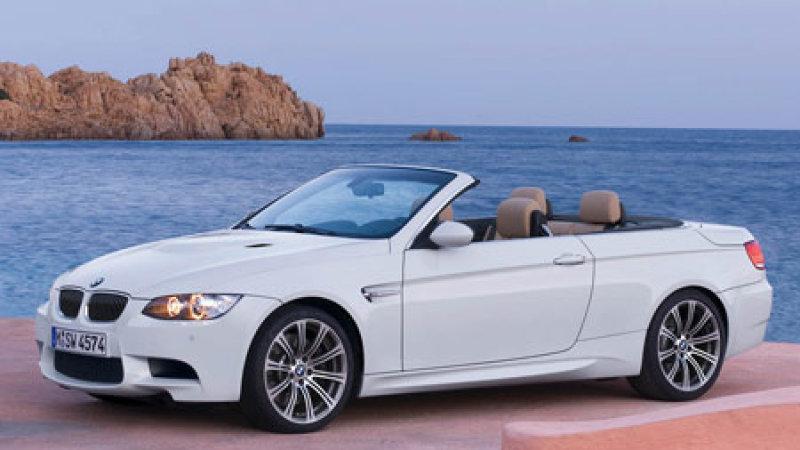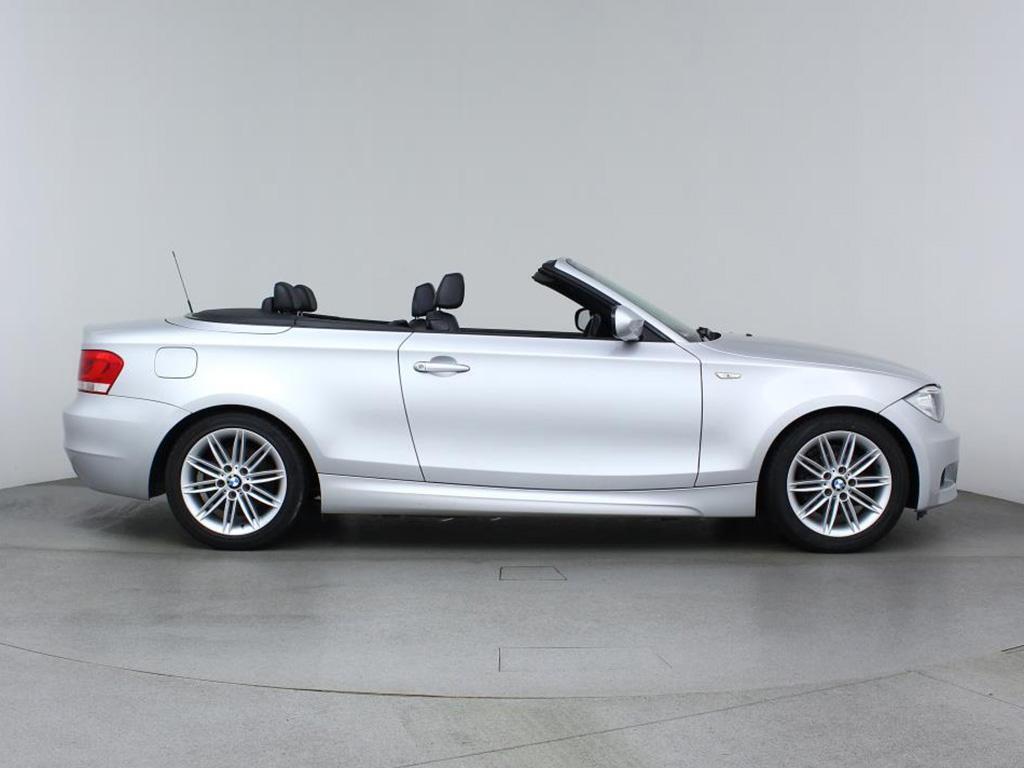The first image is the image on the left, the second image is the image on the right. Analyze the images presented: Is the assertion "There is no less than one black convertible car with its top down" valid? Answer yes or no. No. The first image is the image on the left, the second image is the image on the right. For the images shown, is this caption "One image shows a topless black convertible aimed leftward." true? Answer yes or no. No. 